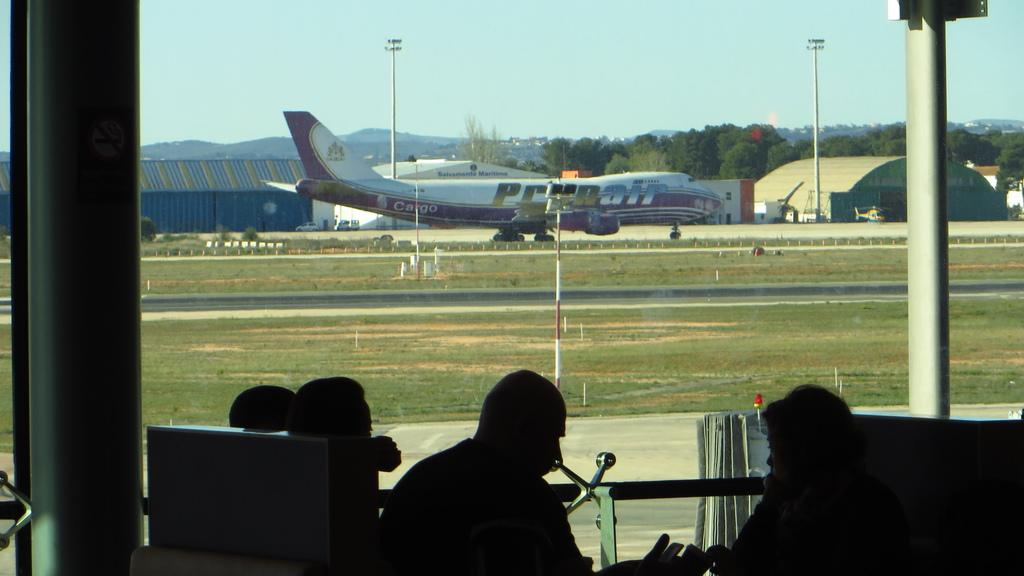Provide a one-sentence caption for the provided image. A photo of a plane at an airport labeled cargo. 